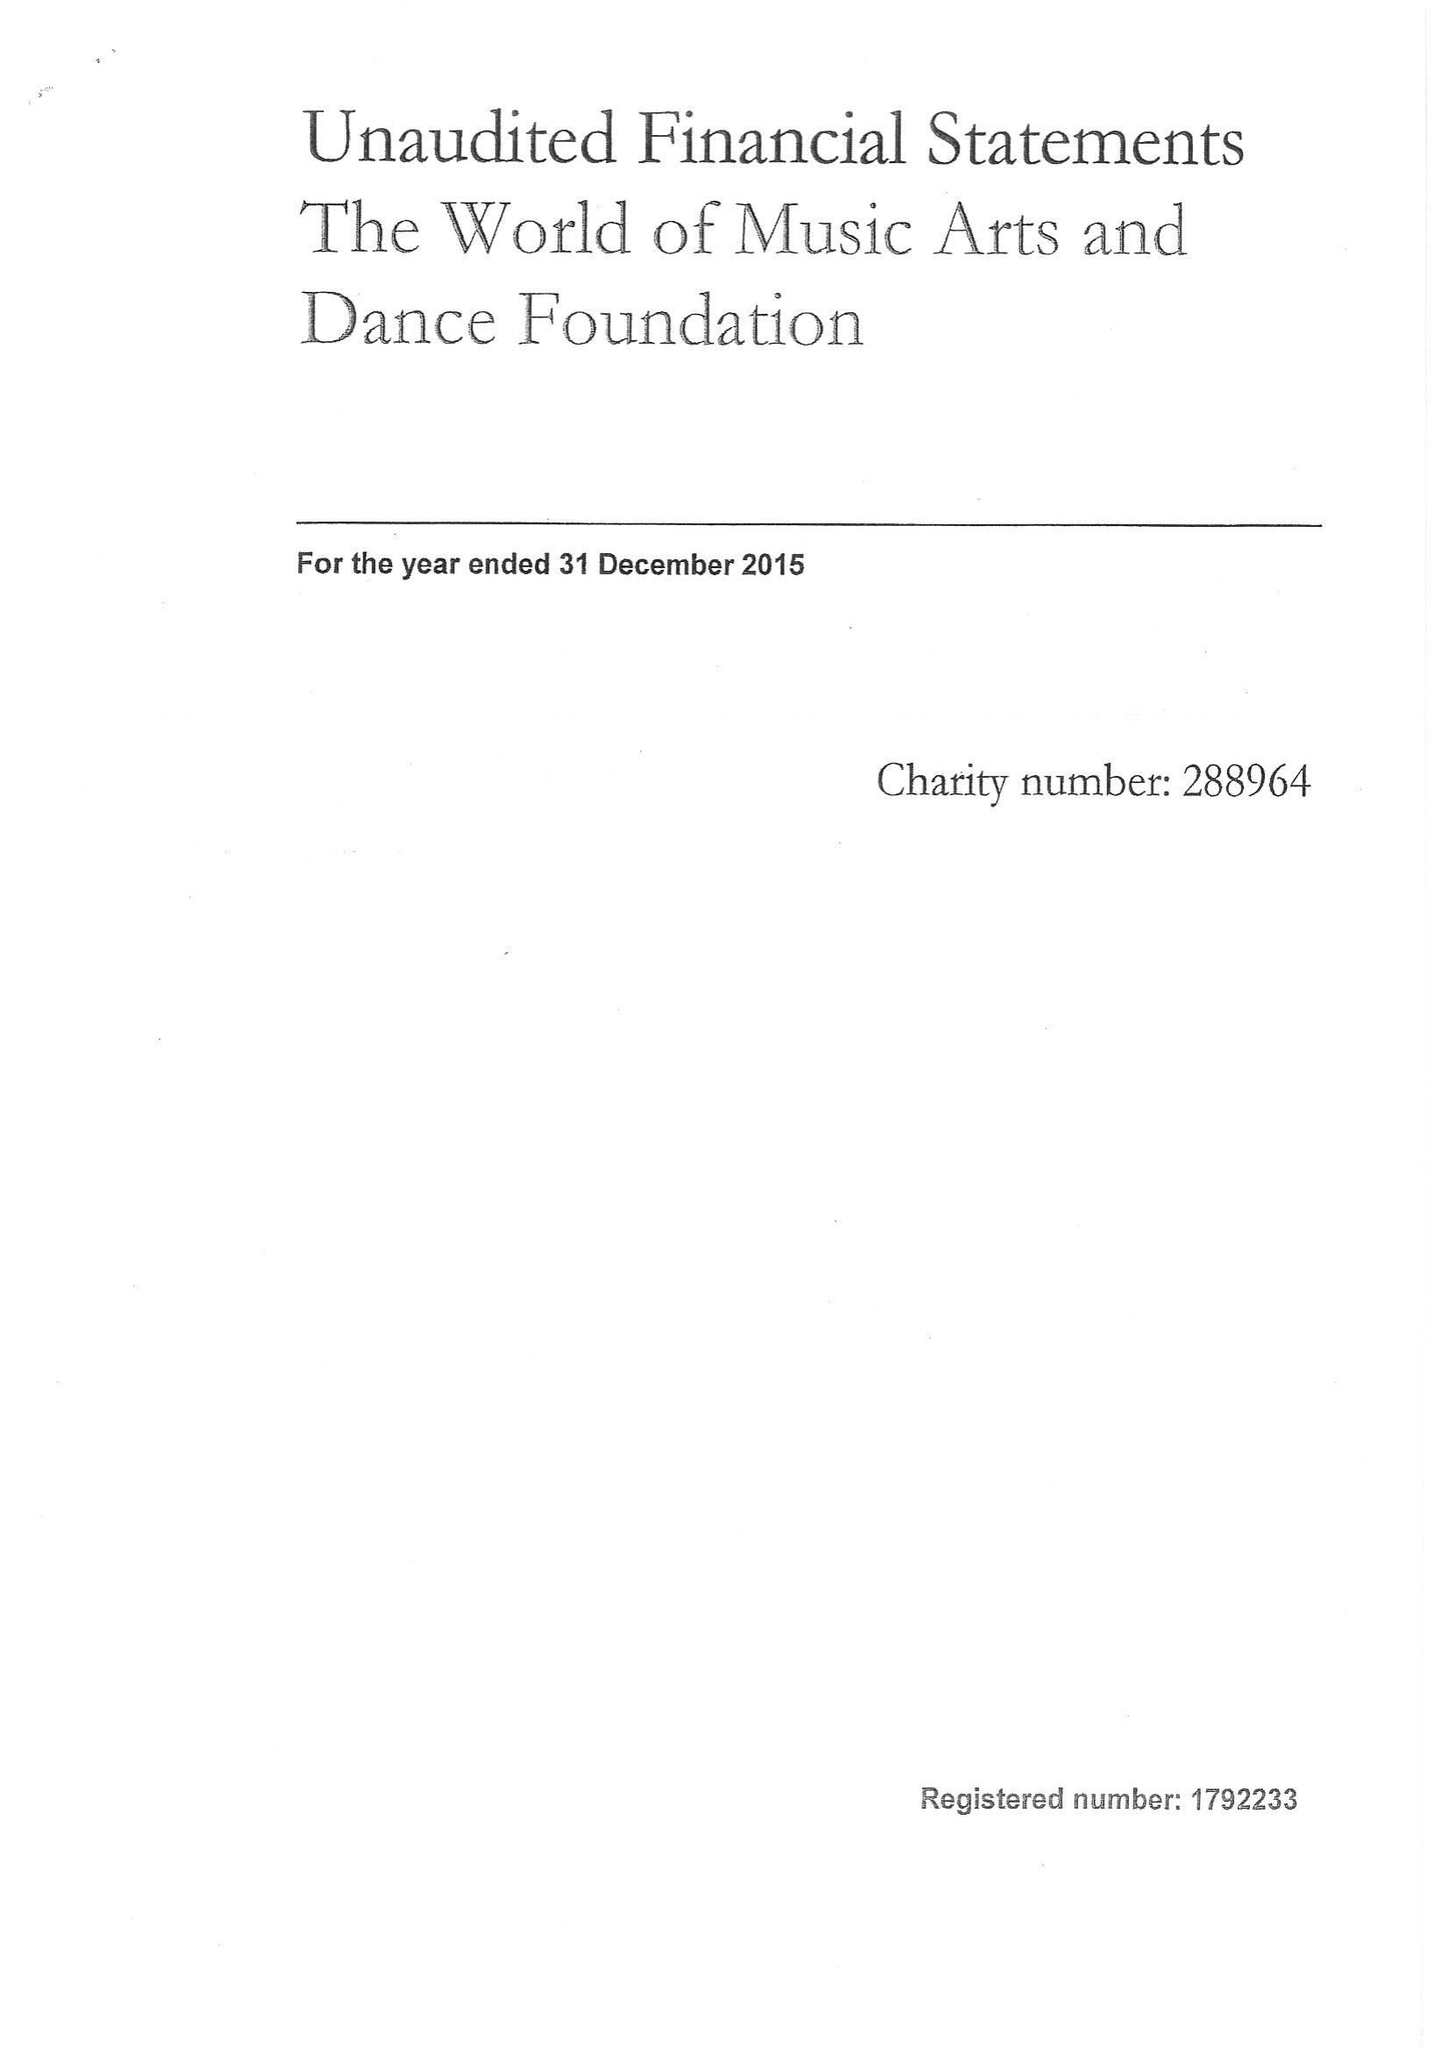What is the value for the income_annually_in_british_pounds?
Answer the question using a single word or phrase. 70843.00 